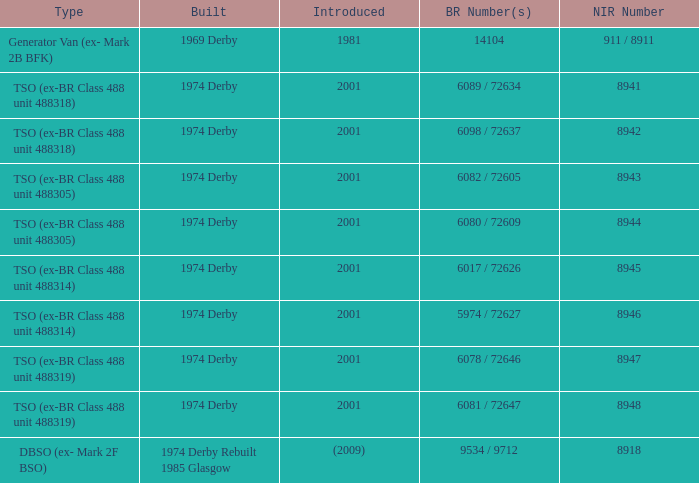Which NIR number is for the tso (ex-br class 488 unit 488305) type that has a 6082 / 72605 BR number? 8943.0. Give me the full table as a dictionary. {'header': ['Type', 'Built', 'Introduced', 'BR Number(s)', 'NIR Number'], 'rows': [['Generator Van (ex- Mark 2B BFK)', '1969 Derby', '1981', '14104', '911 / 8911'], ['TSO (ex-BR Class 488 unit 488318)', '1974 Derby', '2001', '6089 / 72634', '8941'], ['TSO (ex-BR Class 488 unit 488318)', '1974 Derby', '2001', '6098 / 72637', '8942'], ['TSO (ex-BR Class 488 unit 488305)', '1974 Derby', '2001', '6082 / 72605', '8943'], ['TSO (ex-BR Class 488 unit 488305)', '1974 Derby', '2001', '6080 / 72609', '8944'], ['TSO (ex-BR Class 488 unit 488314)', '1974 Derby', '2001', '6017 / 72626', '8945'], ['TSO (ex-BR Class 488 unit 488314)', '1974 Derby', '2001', '5974 / 72627', '8946'], ['TSO (ex-BR Class 488 unit 488319)', '1974 Derby', '2001', '6078 / 72646', '8947'], ['TSO (ex-BR Class 488 unit 488319)', '1974 Derby', '2001', '6081 / 72647', '8948'], ['DBSO (ex- Mark 2F BSO)', '1974 Derby Rebuilt 1985 Glasgow', '(2009)', '9534 / 9712', '8918']]} 